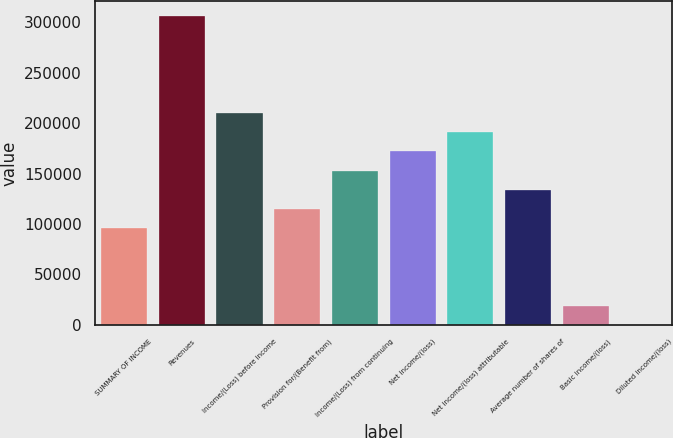<chart> <loc_0><loc_0><loc_500><loc_500><bar_chart><fcel>SUMMARY OF INCOME<fcel>Revenues<fcel>Income/(Loss) before income<fcel>Provision for/(Benefit from)<fcel>Income/(Loss) from continuing<fcel>Net income/(loss)<fcel>Net income/(loss) attributable<fcel>Average number of shares of<fcel>Basic income/(loss)<fcel>Diluted income/(loss)<nl><fcel>95609.7<fcel>305948<fcel>210340<fcel>114731<fcel>152975<fcel>172096<fcel>191218<fcel>133853<fcel>19123.1<fcel>1.42<nl></chart> 